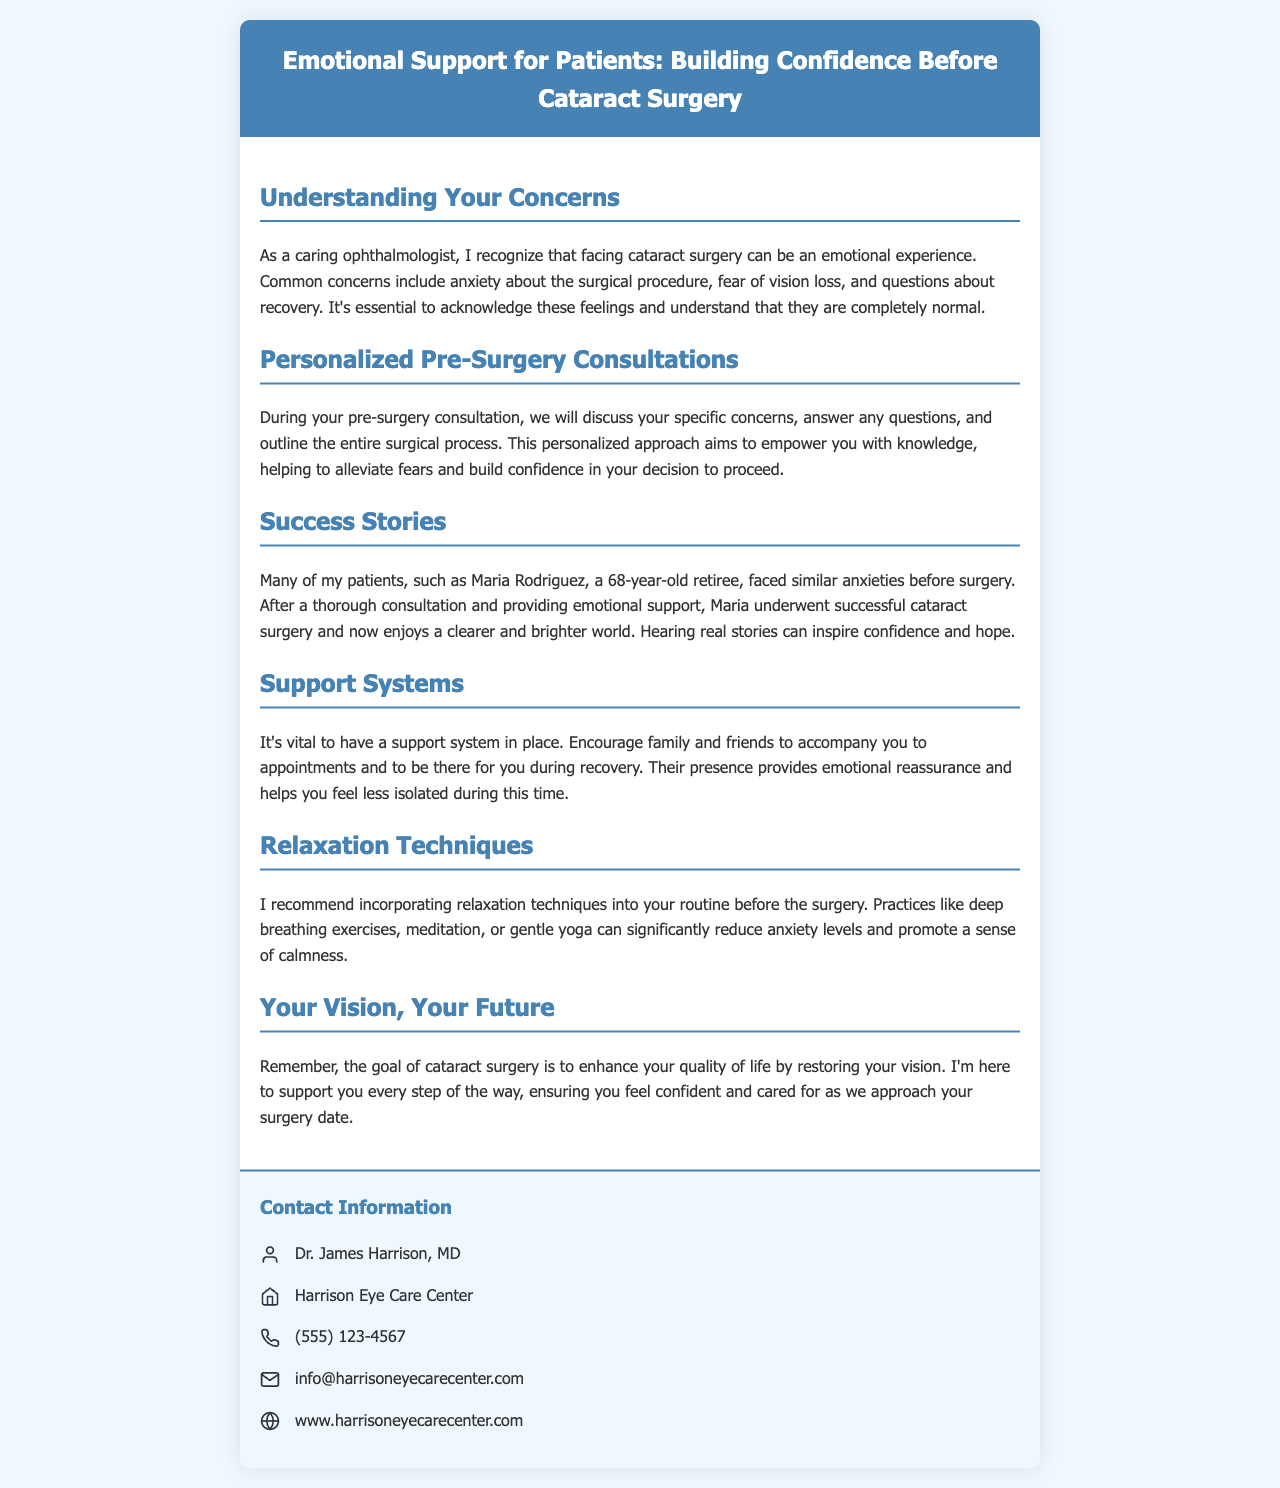What is the title of the brochure? The title is displayed prominently at the top of the brochure, summarizing its main focus.
Answer: Emotional Support for Patients: Building Confidence Before Cataract Surgery Who is the author of the brochure? The author is mentioned in the contact section, indicating who is providing the information.
Answer: Dr. James Harrison, MD What emotional concern do patients commonly have before cataract surgery? This is identified in the content, highlighting a specific anxiety experienced by patients.
Answer: Fear of vision loss What relaxation techniques are recommended? The section includes specific techniques suggested to help reduce anxiety before the surgery.
Answer: Deep breathing exercises What success story is mentioned in the brochure? The brochure provides an example of a patient whose experience illustrates positive outcomes from surgery.
Answer: Maria Rodriguez How should patients prepare emotionally before surgery? The document details several methods to support emotional well-being leading up to the surgery date.
Answer: Support systems What is the purpose of the cataract surgery according to the brochure? The brochure shares the ultimate goal of the surgical procedure as understood by the ophthalmologist.
Answer: Enhance your quality of life by restoring your vision What kind of support should family and friends provide during recovery? The content emphasizes the importance of having emotional reassurance during the recovery phase.
Answer: Emotional reassurance 